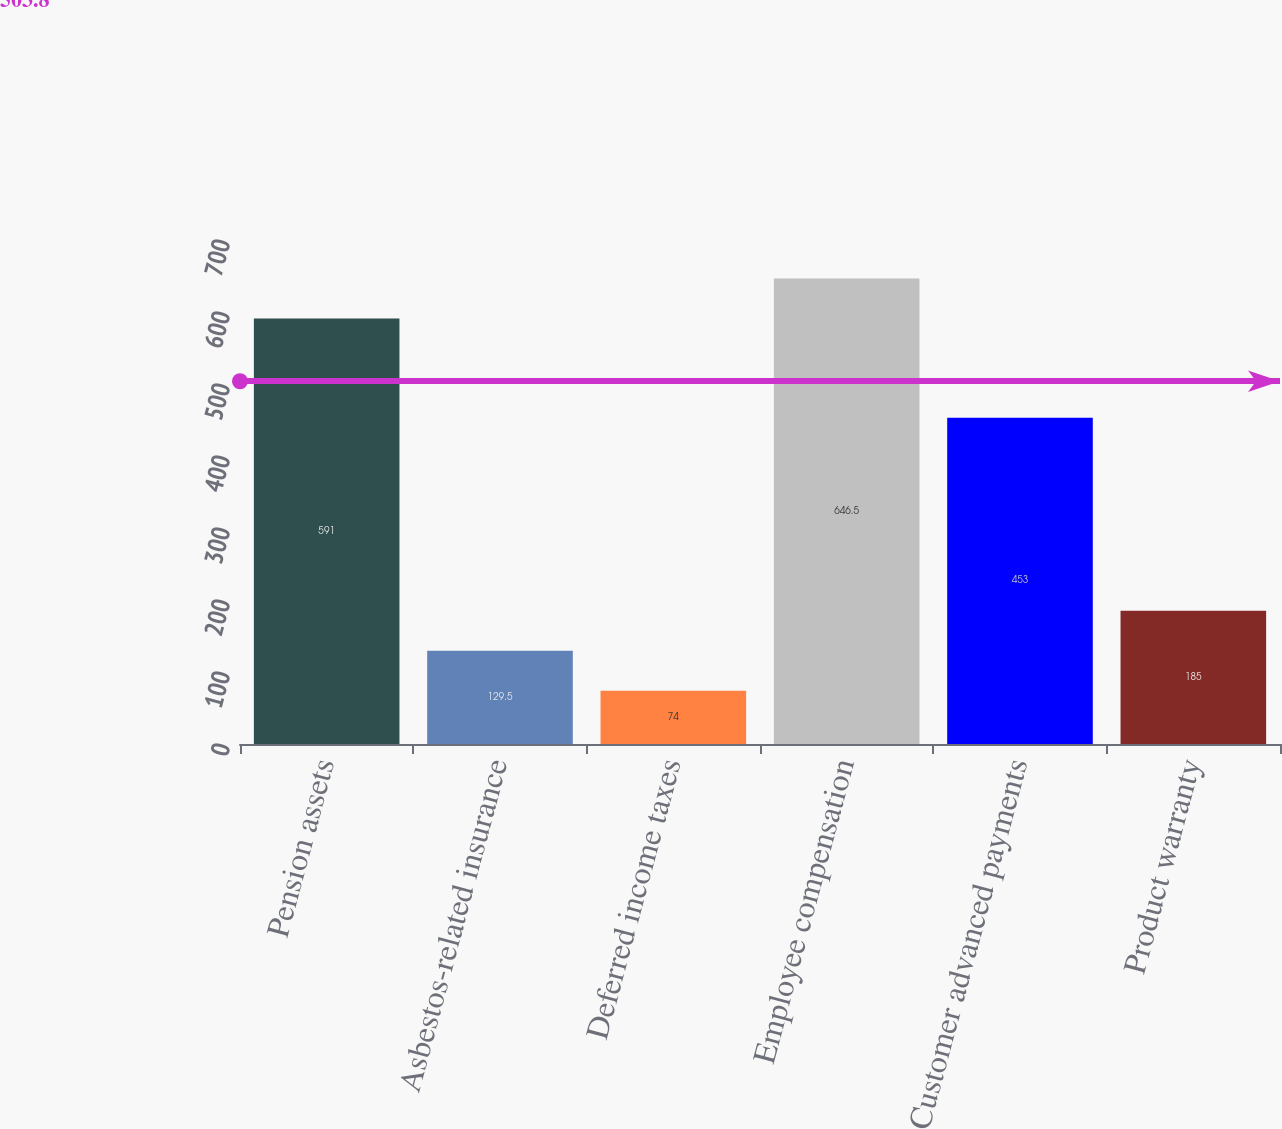Convert chart. <chart><loc_0><loc_0><loc_500><loc_500><bar_chart><fcel>Pension assets<fcel>Asbestos-related insurance<fcel>Deferred income taxes<fcel>Employee compensation<fcel>Customer advanced payments<fcel>Product warranty<nl><fcel>591<fcel>129.5<fcel>74<fcel>646.5<fcel>453<fcel>185<nl></chart> 